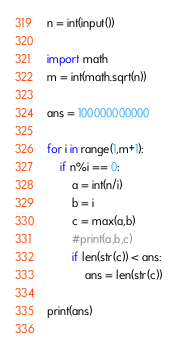Convert code to text. <code><loc_0><loc_0><loc_500><loc_500><_Python_>n = int(input())

import math
m = int(math.sqrt(n))

ans = 100000000000

for i in range(1,m+1):
	if n%i == 0:
		a = int(n/i)
		b = i
		c = max(a,b)
		#print(a,b,c)
		if len(str(c)) < ans:
			ans = len(str(c))

print(ans)
		

</code> 